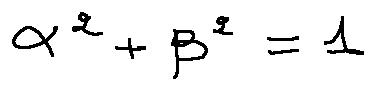<formula> <loc_0><loc_0><loc_500><loc_500>\alpha ^ { 2 } + \beta ^ { 2 } = 1</formula> 